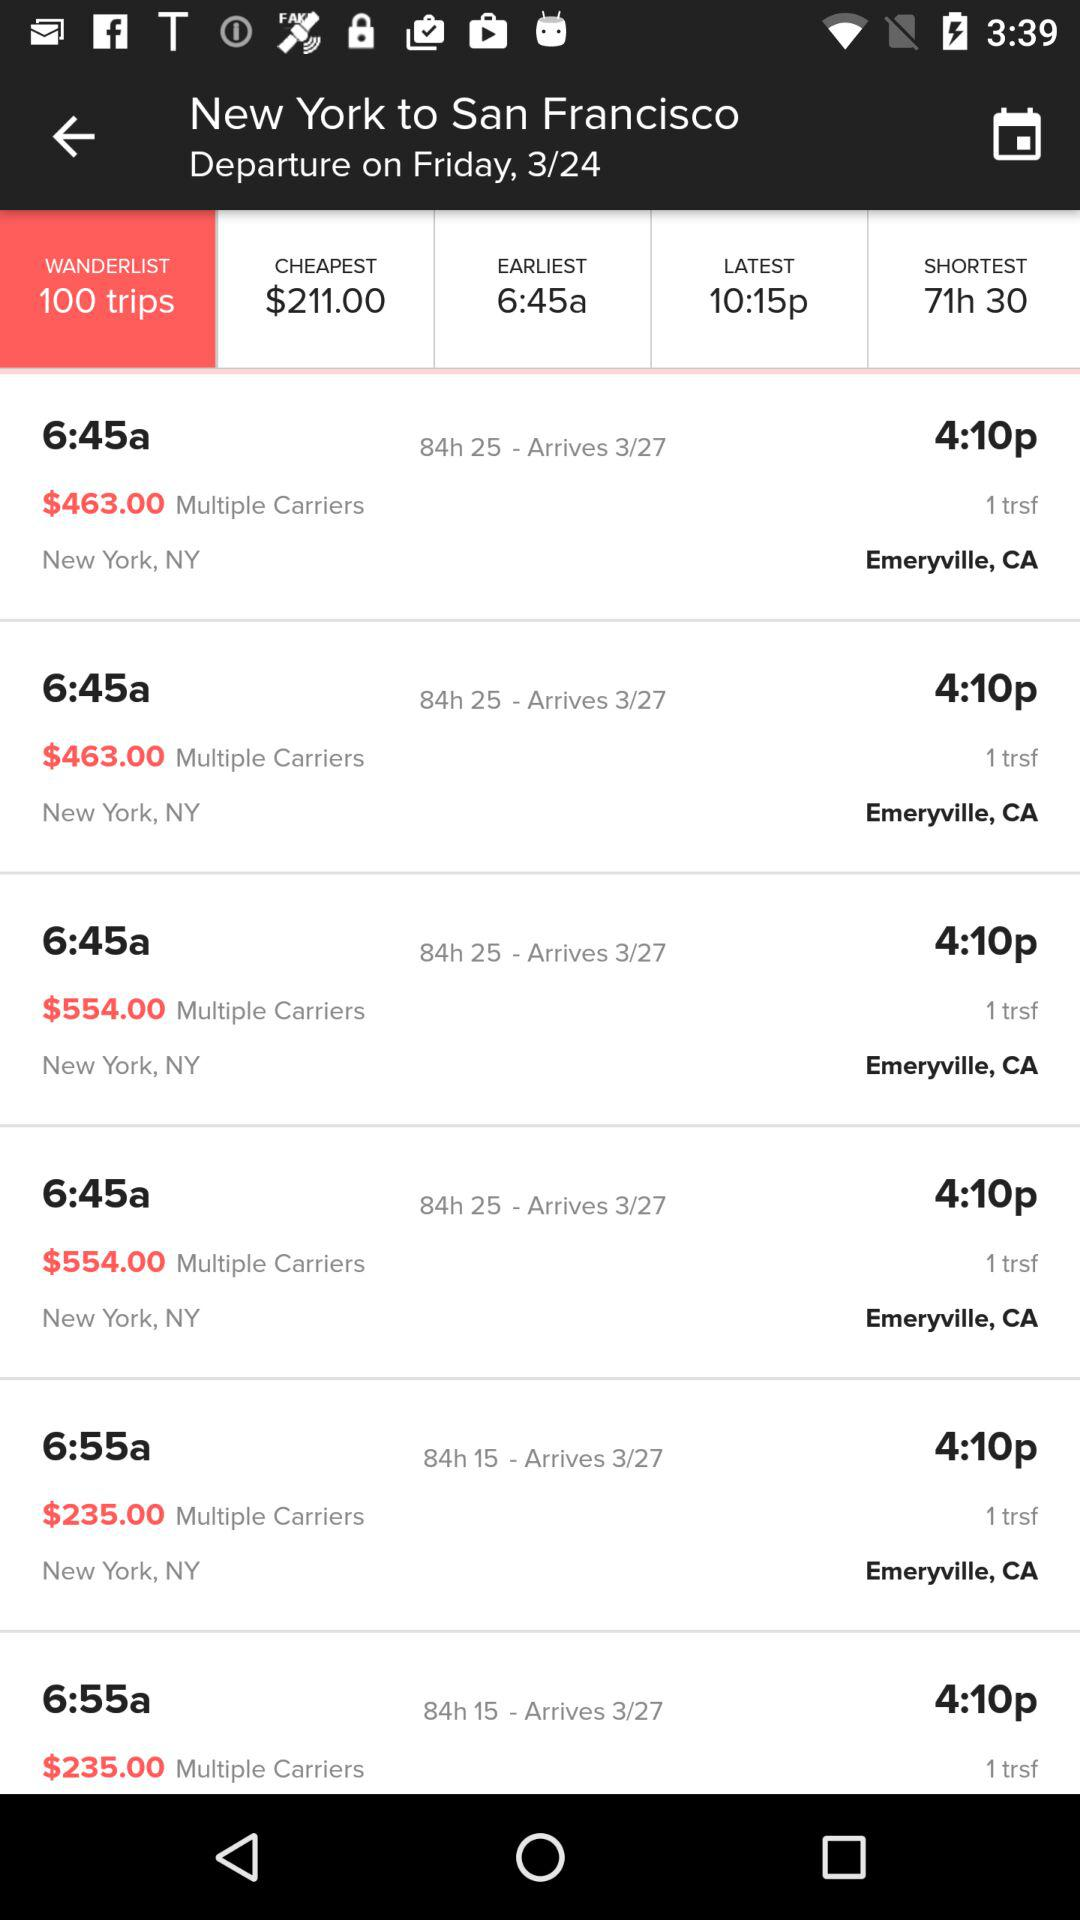What is the shortest time duration? The shortest time duration is 71 hours 30 minutes. 